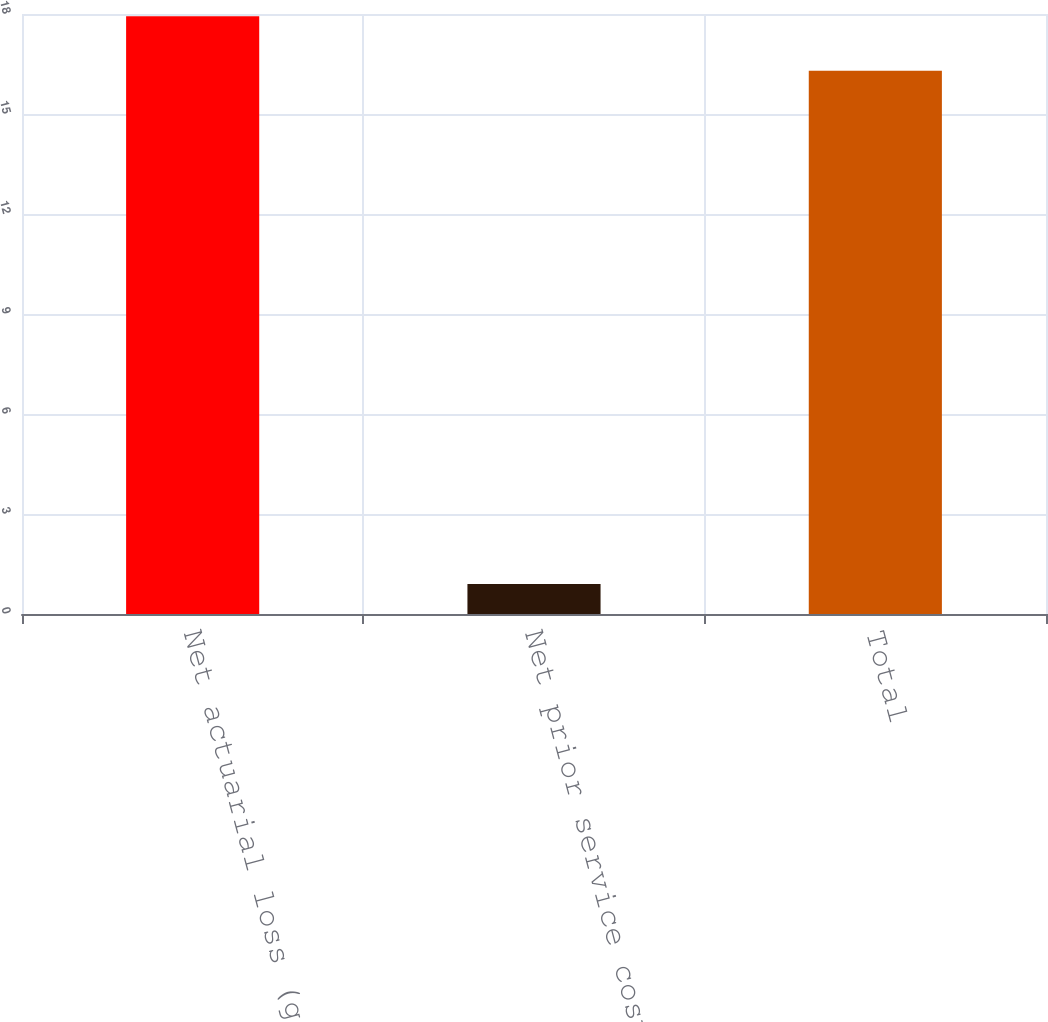Convert chart. <chart><loc_0><loc_0><loc_500><loc_500><bar_chart><fcel>Net actuarial loss (gain)<fcel>Net prior service costs<fcel>Total<nl><fcel>17.93<fcel>0.9<fcel>16.3<nl></chart> 